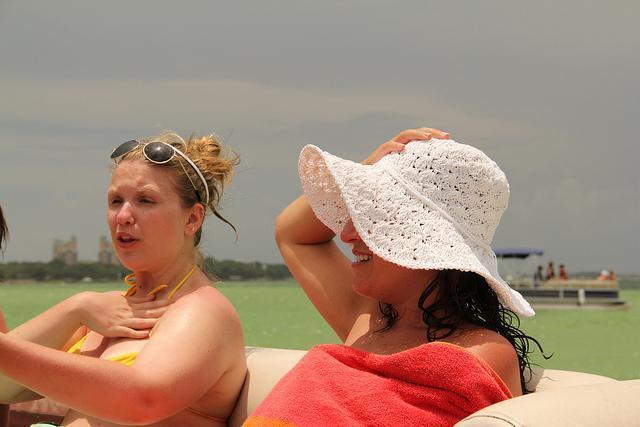How many people can you see?
Give a very brief answer. 2. 